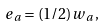<formula> <loc_0><loc_0><loc_500><loc_500>{ e _ { a } } = ( 1 / 2 ) { w _ { a } } \, ,</formula> 